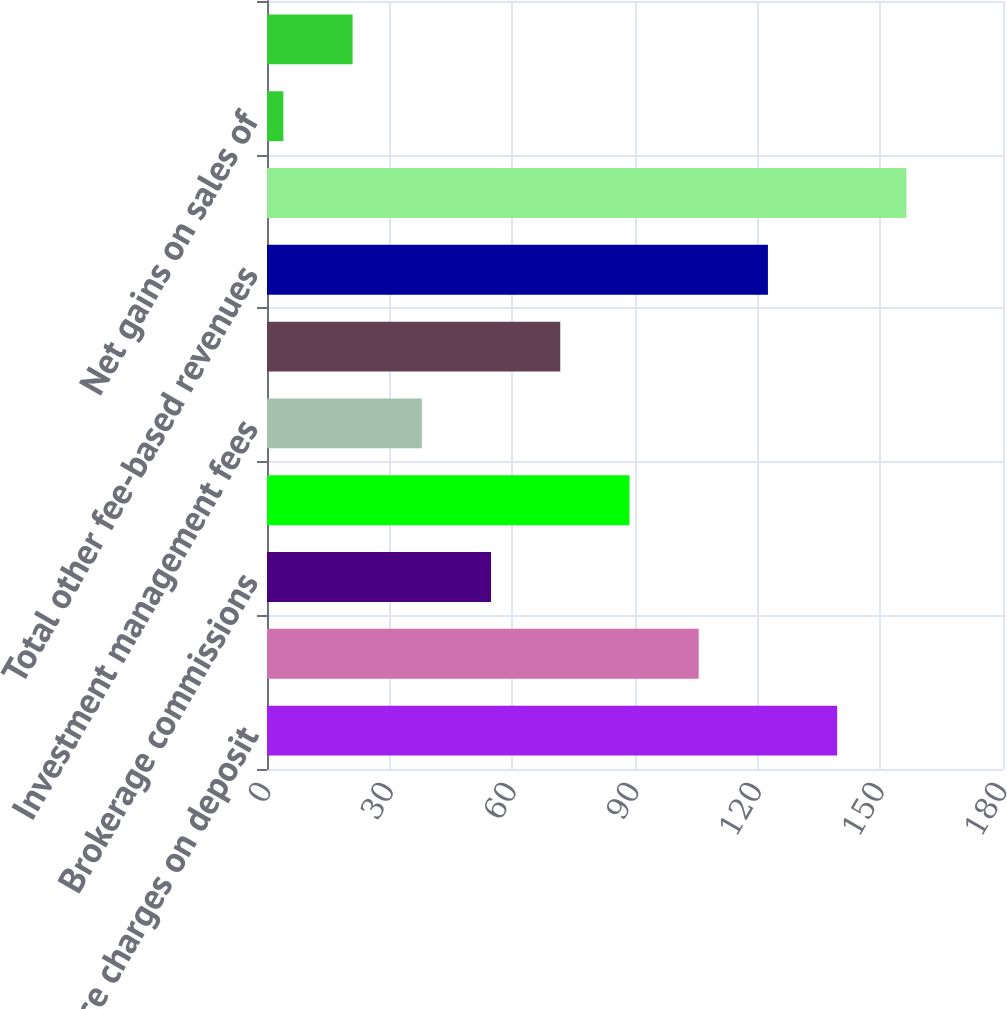Convert chart to OTSL. <chart><loc_0><loc_0><loc_500><loc_500><bar_chart><fcel>Service charges on deposit<fcel>Insurance revenue<fcel>Brokerage commissions<fcel>Other banking service charges<fcel>Investment management fees<fcel>Other fees<fcel>Total other fee-based revenues<fcel>Total fee-based revenues<fcel>Net gains on sales of<fcel>Other non-interest income<nl><fcel>139.44<fcel>105.58<fcel>54.79<fcel>88.65<fcel>37.86<fcel>71.72<fcel>122.51<fcel>156.37<fcel>4<fcel>20.93<nl></chart> 